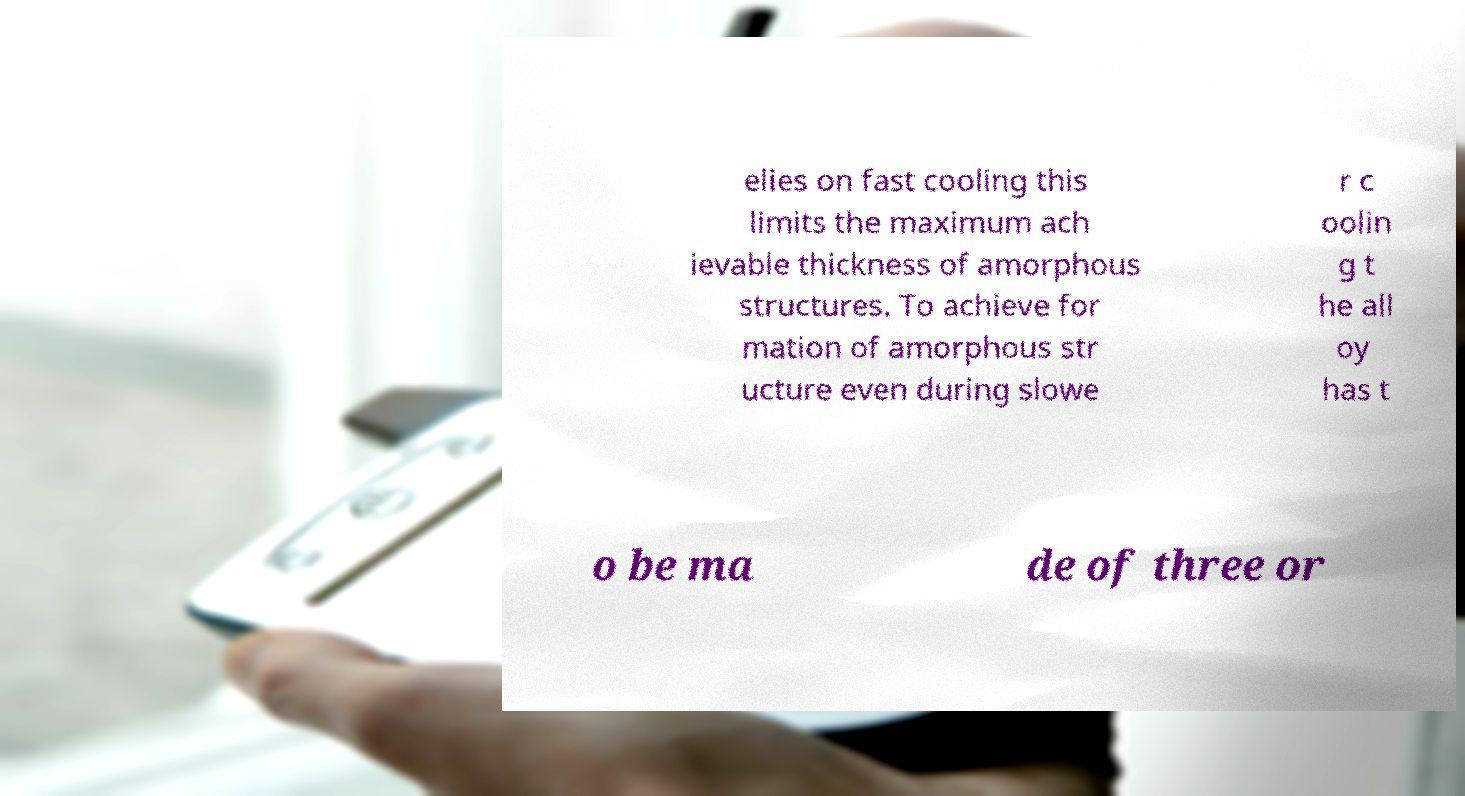Can you accurately transcribe the text from the provided image for me? elies on fast cooling this limits the maximum ach ievable thickness of amorphous structures. To achieve for mation of amorphous str ucture even during slowe r c oolin g t he all oy has t o be ma de of three or 